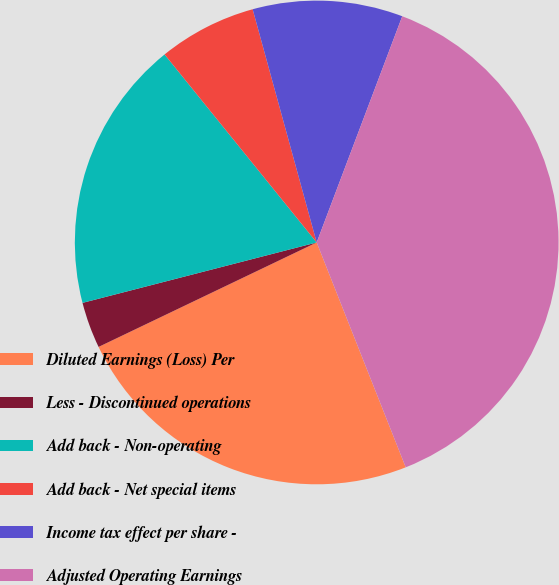Convert chart. <chart><loc_0><loc_0><loc_500><loc_500><pie_chart><fcel>Diluted Earnings (Loss) Per<fcel>Less - Discontinued operations<fcel>Add back - Non-operating<fcel>Add back - Net special items<fcel>Income tax effect per share -<fcel>Adjusted Operating Earnings<nl><fcel>23.89%<fcel>3.09%<fcel>18.19%<fcel>6.56%<fcel>10.02%<fcel>38.24%<nl></chart> 